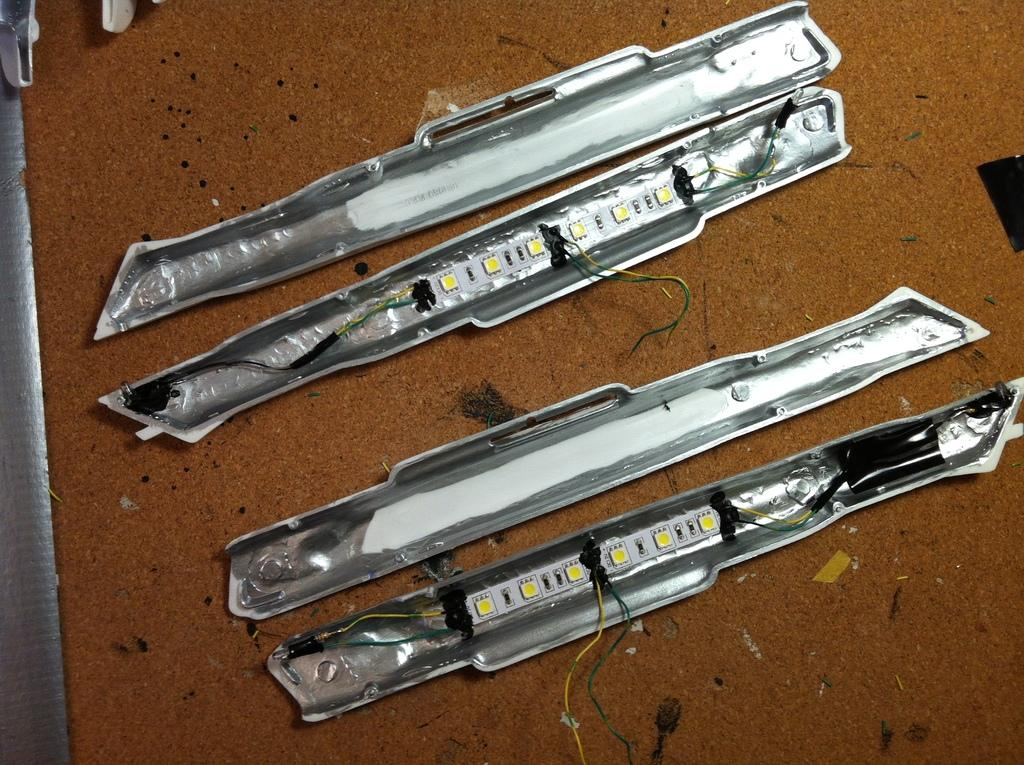What is the color of the surface on which the objects are placed in the image? The surface is brown in color. Can you describe any specific objects or features visible on the surface? There are wires visible on the surface. What type of rule is being enforced at the airport in the image? There is no airport or rule present in the image; it only features objects on a brown surface with visible wires. How many ducks can be seen swimming in the water in the image? There are no ducks or water present in the image; it only features objects on a brown surface with visible wires. 